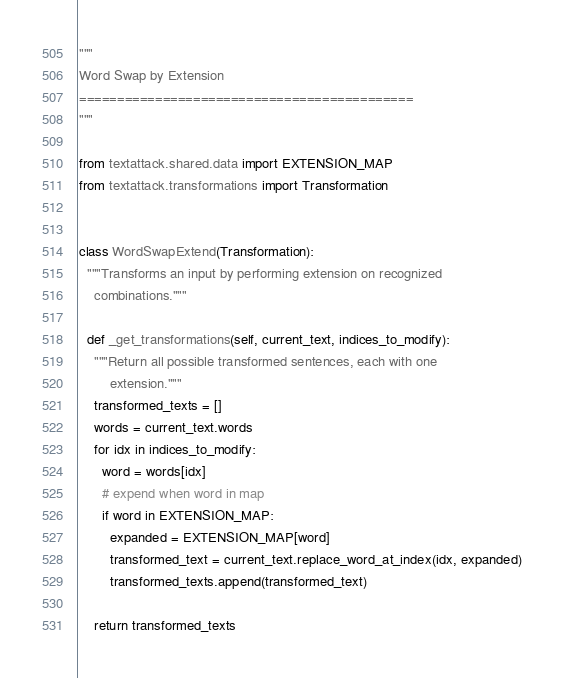Convert code to text. <code><loc_0><loc_0><loc_500><loc_500><_Python_>"""
Word Swap by Extension
============================================
"""

from textattack.shared.data import EXTENSION_MAP
from textattack.transformations import Transformation


class WordSwapExtend(Transformation):
  """Transforms an input by performing extension on recognized
    combinations."""

  def _get_transformations(self, current_text, indices_to_modify):
    """Return all possible transformed sentences, each with one
        extension."""
    transformed_texts = []
    words = current_text.words
    for idx in indices_to_modify:
      word = words[idx]
      # expend when word in map
      if word in EXTENSION_MAP:
        expanded = EXTENSION_MAP[word]
        transformed_text = current_text.replace_word_at_index(idx, expanded)
        transformed_texts.append(transformed_text)

    return transformed_texts
</code> 